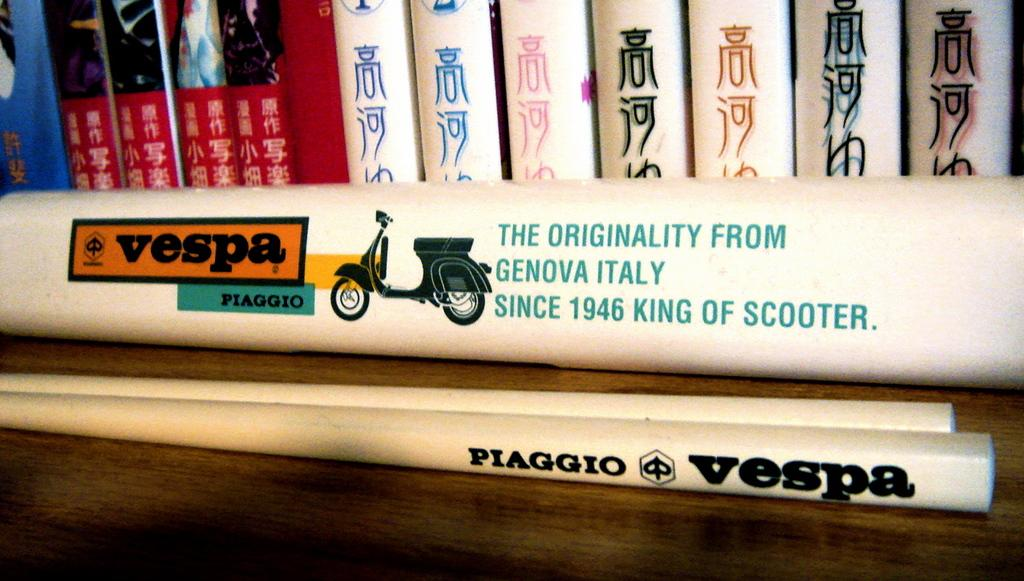<image>
Provide a brief description of the given image. books lined up near a Vespa Piaggio sign 